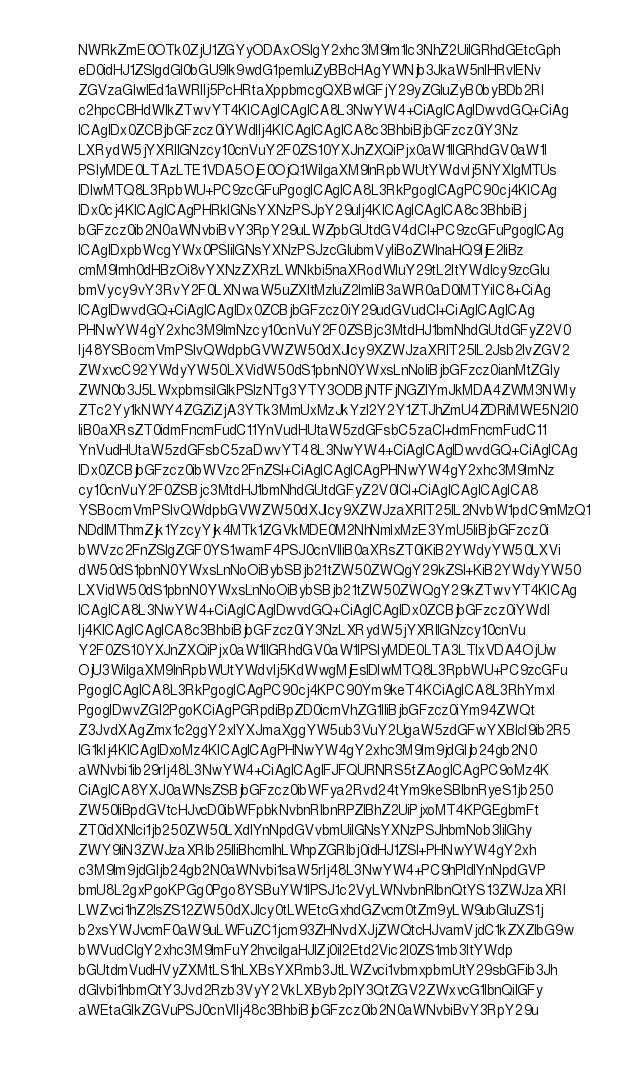<code> <loc_0><loc_0><loc_500><loc_500><_YAML_>        NWRkZmE0OTk0ZjU1ZGYyODAxOSIgY2xhc3M9Im1lc3NhZ2UiIGRhdGEtcGph
        eD0idHJ1ZSIgdGl0bGU9Ik9wdG1pemluZyBBcHAgYWNjb3JkaW5nIHRvIENv
        ZGVzaGlwIEd1aWRlIj5PcHRtaXppbmcgQXBwIGFjY29yZGluZyB0byBDb2Rl
        c2hpcCBHdWlkZTwvYT4KICAgICAgICA8L3NwYW4+CiAgICAgIDwvdGQ+CiAg
        ICAgIDx0ZCBjbGFzcz0iYWdlIj4KICAgICAgICA8c3BhbiBjbGFzcz0iY3Nz
        LXRydW5jYXRlIGNzcy10cnVuY2F0ZS10YXJnZXQiPjx0aW1lIGRhdGV0aW1l
        PSIyMDE0LTAzLTE1VDA5OjE0OjQ1WiIgaXM9InRpbWUtYWdvIj5NYXIgMTUs
        IDIwMTQ8L3RpbWU+PC9zcGFuPgogICAgICA8L3RkPgogICAgPC90cj4KICAg
        IDx0cj4KICAgICAgPHRkIGNsYXNzPSJpY29uIj4KICAgICAgICA8c3BhbiBj
        bGFzcz0ib2N0aWNvbiBvY3RpY29uLWZpbGUtdGV4dCI+PC9zcGFuPgogICAg
        ICAgIDxpbWcgYWx0PSIiIGNsYXNzPSJzcGlubmVyIiBoZWlnaHQ9IjE2IiBz
        cmM9Imh0dHBzOi8vYXNzZXRzLWNkbi5naXRodWIuY29tL2ltYWdlcy9zcGlu
        bmVycy9vY3RvY2F0LXNwaW5uZXItMzIuZ2lmIiB3aWR0aD0iMTYiIC8+CiAg
        ICAgIDwvdGQ+CiAgICAgIDx0ZCBjbGFzcz0iY29udGVudCI+CiAgICAgICAg
        PHNwYW4gY2xhc3M9ImNzcy10cnVuY2F0ZSBjc3MtdHJ1bmNhdGUtdGFyZ2V0
        Ij48YSBocmVmPSIvQWdpbGVWZW50dXJlcy9XZWJzaXRlT25lL2Jsb2IvZGV2
        ZWxvcC92YWdyYW50LXVidW50dS1pbnN0YWxsLnNoIiBjbGFzcz0ianMtZGly
        ZWN0b3J5LWxpbmsiIGlkPSIzNTg3YTY3ODBjNTFjNGZlYmJkMDA4ZWM3NWIy
        ZTc2Yy1kNWY4ZGZiZjA3YTk3MmUxMzJkYzI2Y2Y1ZTJhZmU4ZDRiMWE5N2I0
        IiB0aXRsZT0idmFncmFudC11YnVudHUtaW5zdGFsbC5zaCI+dmFncmFudC11
        YnVudHUtaW5zdGFsbC5zaDwvYT48L3NwYW4+CiAgICAgIDwvdGQ+CiAgICAg
        IDx0ZCBjbGFzcz0ibWVzc2FnZSI+CiAgICAgICAgPHNwYW4gY2xhc3M9ImNz
        cy10cnVuY2F0ZSBjc3MtdHJ1bmNhdGUtdGFyZ2V0ICI+CiAgICAgICAgICA8
        YSBocmVmPSIvQWdpbGVWZW50dXJlcy9XZWJzaXRlT25lL2NvbW1pdC9mMzQ1
        NDdlMThmZjk1YzcyYjk4MTk1ZGVkMDE0M2NhNmIxMzE3YmU5IiBjbGFzcz0i
        bWVzc2FnZSIgZGF0YS1wamF4PSJ0cnVlIiB0aXRsZT0iKiB2YWdyYW50LXVi
        dW50dS1pbnN0YWxsLnNoOiBybSBjb21tZW50ZWQgY29kZSI+KiB2YWdyYW50
        LXVidW50dS1pbnN0YWxsLnNoOiBybSBjb21tZW50ZWQgY29kZTwvYT4KICAg
        ICAgICA8L3NwYW4+CiAgICAgIDwvdGQ+CiAgICAgIDx0ZCBjbGFzcz0iYWdl
        Ij4KICAgICAgICA8c3BhbiBjbGFzcz0iY3NzLXRydW5jYXRlIGNzcy10cnVu
        Y2F0ZS10YXJnZXQiPjx0aW1lIGRhdGV0aW1lPSIyMDE0LTA3LTIxVDA4OjUw
        OjU3WiIgaXM9InRpbWUtYWdvIj5KdWwgMjEsIDIwMTQ8L3RpbWU+PC9zcGFu
        PgogICAgICA8L3RkPgogICAgPC90cj4KPC90Ym9keT4KCiAgICA8L3RhYmxl
        PgogIDwvZGl2PgoKCiAgPGRpdiBpZD0icmVhZG1lIiBjbGFzcz0iYm94ZWQt
        Z3JvdXAgZmx1c2ggY2xlYXJmaXggYW5ub3VuY2UgaW5zdGFwYXBlcl9ib2R5
        IG1kIj4KICAgIDxoMz4KICAgICAgPHNwYW4gY2xhc3M9Im9jdGljb24gb2N0
        aWNvbi1ib29rIj48L3NwYW4+CiAgICAgIFJFQURNRS5tZAogICAgPC9oMz4K
        CiAgICA8YXJ0aWNsZSBjbGFzcz0ibWFya2Rvd24tYm9keSBlbnRyeS1jb250
        ZW50IiBpdGVtcHJvcD0ibWFpbkNvbnRlbnRPZlBhZ2UiPjxoMT4KPGEgbmFt
        ZT0idXNlci1jb250ZW50LXdlYnNpdGVvbmUiIGNsYXNzPSJhbmNob3IiIGhy
        ZWY9IiN3ZWJzaXRlb25lIiBhcmlhLWhpZGRlbj0idHJ1ZSI+PHNwYW4gY2xh
        c3M9Im9jdGljb24gb2N0aWNvbi1saW5rIj48L3NwYW4+PC9hPldlYnNpdGVP
        bmU8L2gxPgoKPGg0Pgo8YSBuYW1lPSJ1c2VyLWNvbnRlbnQtYS13ZWJzaXRl
        LWZvci1hZ2lsZS12ZW50dXJlcy0tLWEtcGxhdGZvcm0tZm9yLW9ubGluZS1j
        b2xsYWJvcmF0aW9uLWFuZC1jcm93ZHNvdXJjZWQtcHJvamVjdC1kZXZlbG9w
        bWVudCIgY2xhc3M9ImFuY2hvciIgaHJlZj0iI2Etd2Vic2l0ZS1mb3ItYWdp
        bGUtdmVudHVyZXMtLS1hLXBsYXRmb3JtLWZvci1vbmxpbmUtY29sbGFib3Jh
        dGlvbi1hbmQtY3Jvd2Rzb3VyY2VkLXByb2plY3QtZGV2ZWxvcG1lbnQiIGFy
        aWEtaGlkZGVuPSJ0cnVlIj48c3BhbiBjbGFzcz0ib2N0aWNvbiBvY3RpY29u</code> 